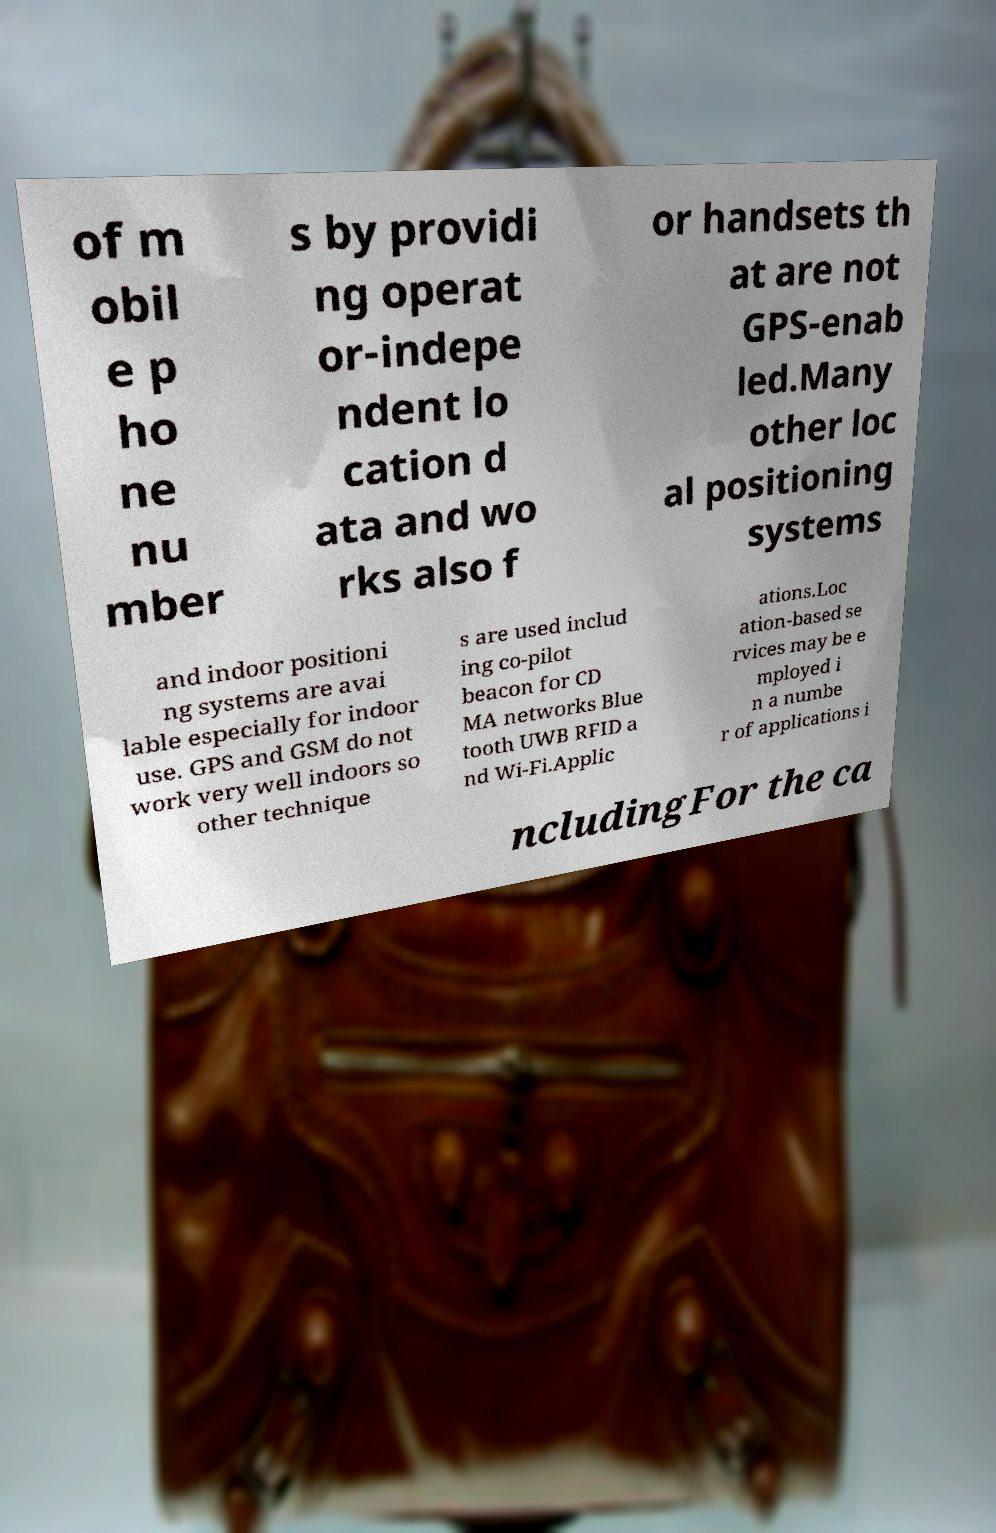I need the written content from this picture converted into text. Can you do that? of m obil e p ho ne nu mber s by providi ng operat or-indepe ndent lo cation d ata and wo rks also f or handsets th at are not GPS-enab led.Many other loc al positioning systems and indoor positioni ng systems are avai lable especially for indoor use. GPS and GSM do not work very well indoors so other technique s are used includ ing co-pilot beacon for CD MA networks Blue tooth UWB RFID a nd Wi-Fi.Applic ations.Loc ation-based se rvices may be e mployed i n a numbe r of applications i ncludingFor the ca 